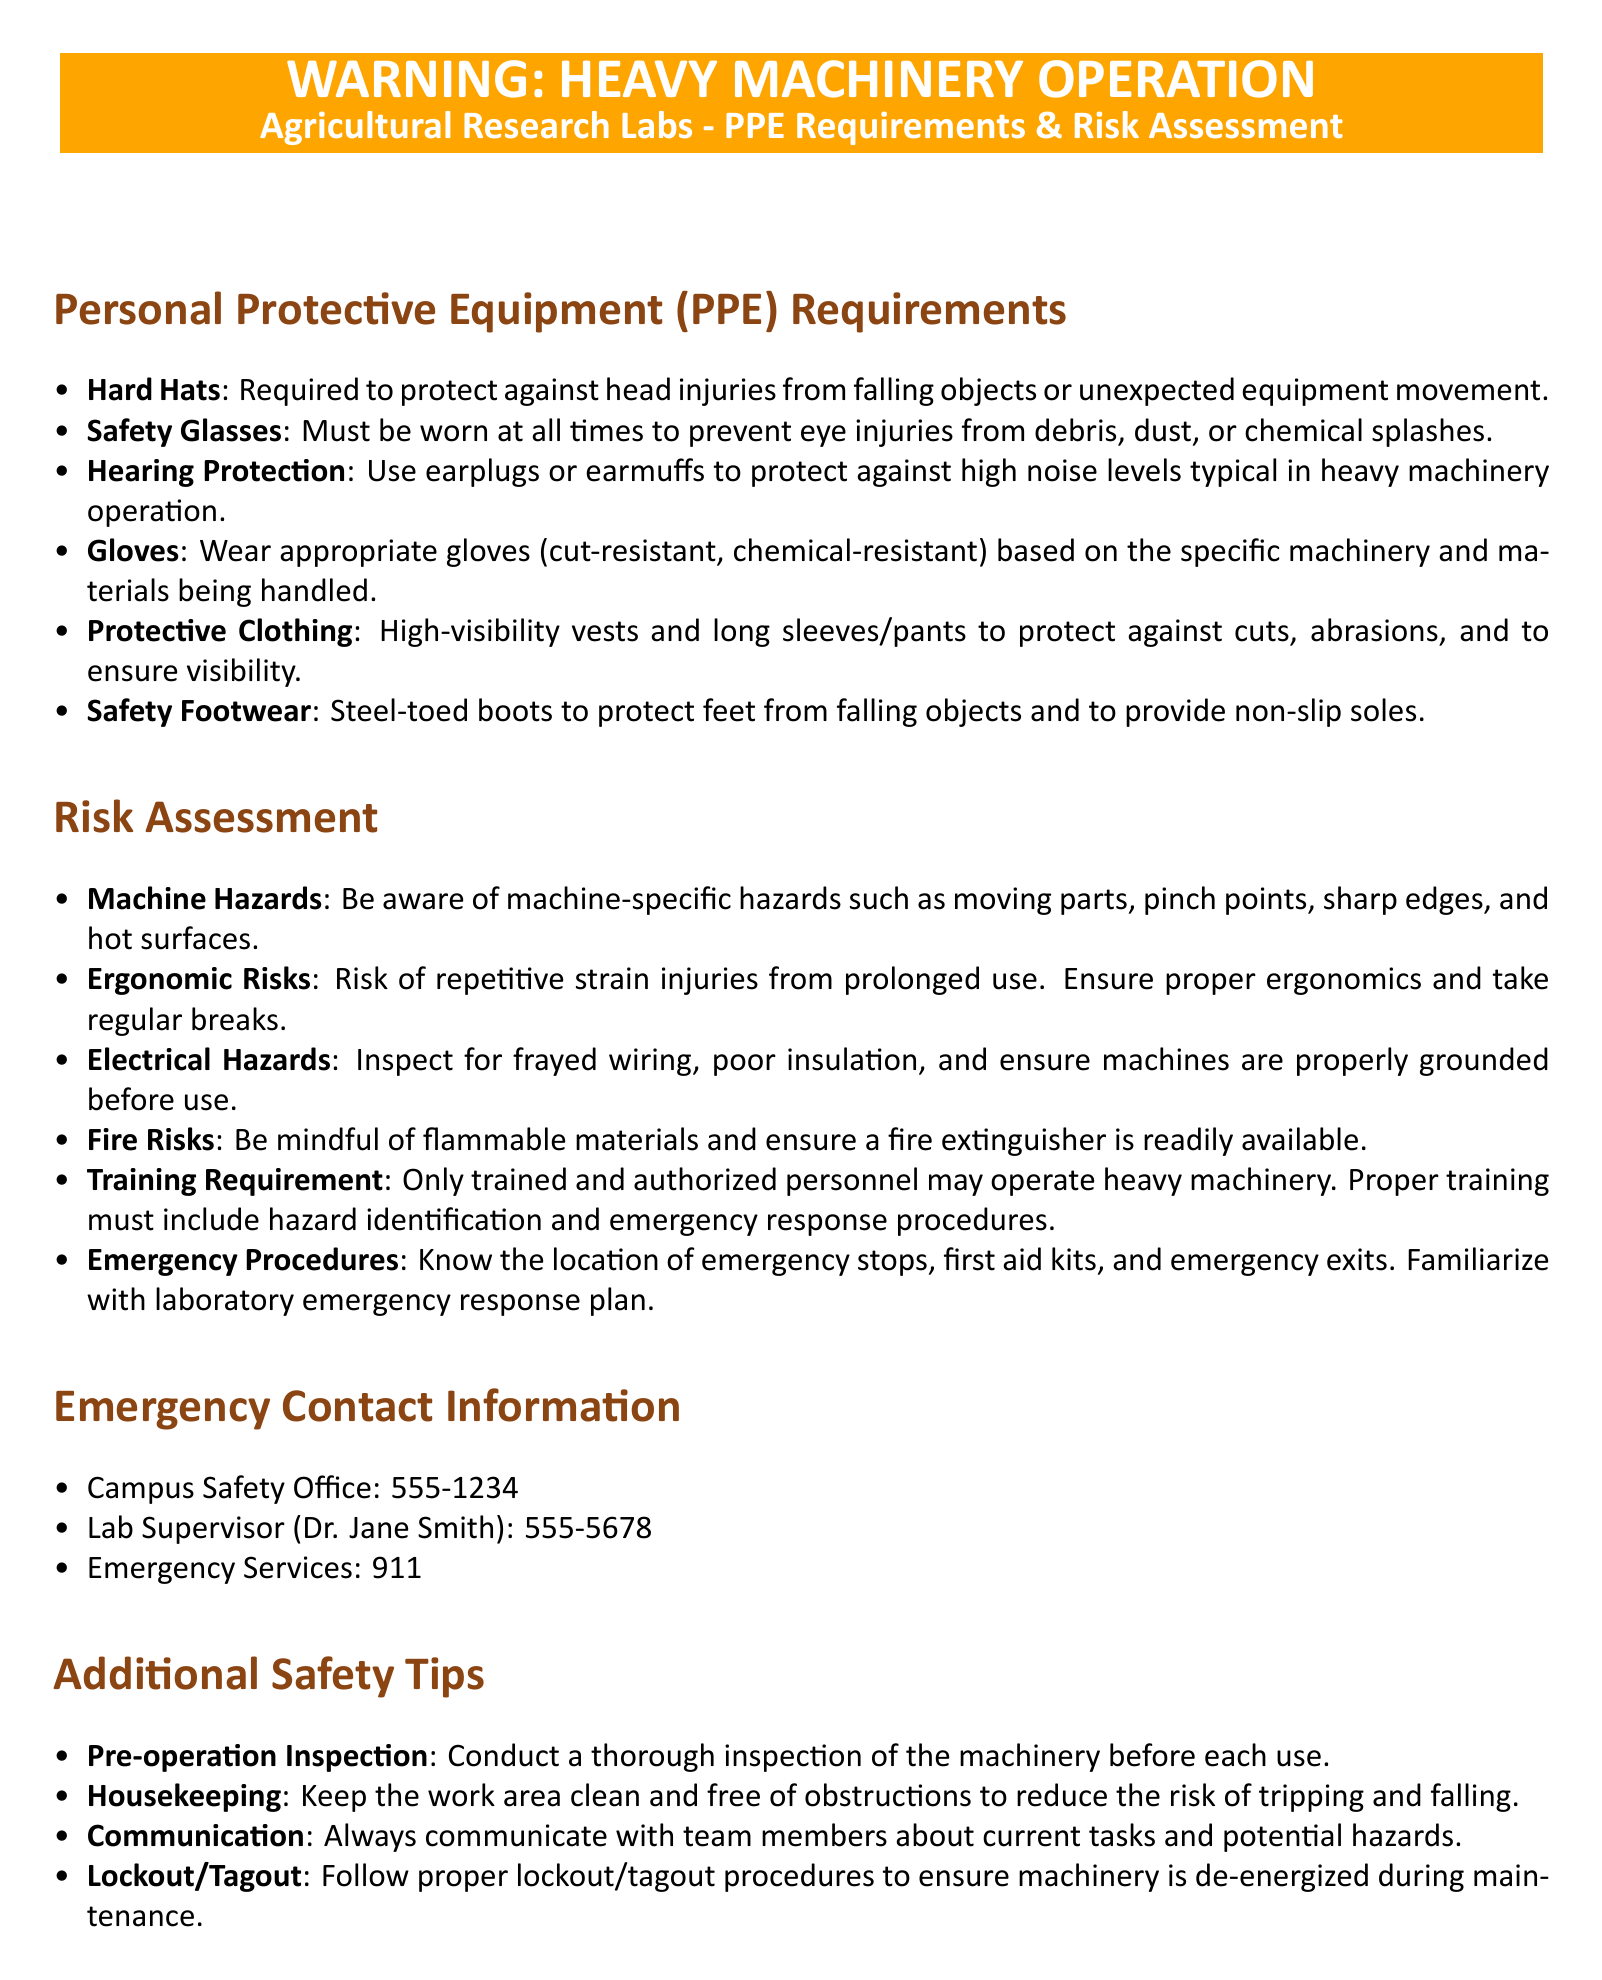What is required to protect against head injuries? The document states that hard hats are required to protect against head injuries.
Answer: Hard Hats What must be worn at all times to prevent eye injuries? The document specifies that safety glasses must be worn at all times to prevent eye injuries.
Answer: Safety Glasses Which personal protective equipment category includes steel-toed boots? The relevant section in the document describes safety footwear, which includes steel-toed boots.
Answer: Safety Footwear What should you inspect for before using machinery? The risk assessment section mentions inspecting for frayed wiring and poor insulation before using machinery.
Answer: Frayed wiring, poor insulation What is a required procedure when maintaining machinery? The document emphasizes following proper lockout/tagout procedures during machine maintenance.
Answer: Lockout/Tagout How many emergency contact numbers are listed? The document provides three emergency contact numbers for different services.
Answer: Three What is the significance of proper ergonomics mentioned in the document? The document highlights the risk of repetitive strain injuries from prolonged use, indicating the importance of ergonomics.
Answer: Ergonomic Risks Who is the lab supervisor mentioned in the document? The emergency contact section names Dr. Jane Smith as the lab supervisor.
Answer: Dr. Jane Smith What type of operation inspection is advised? The document suggests conducting a thorough inspection of the machinery before each use.
Answer: Pre-operation Inspection 